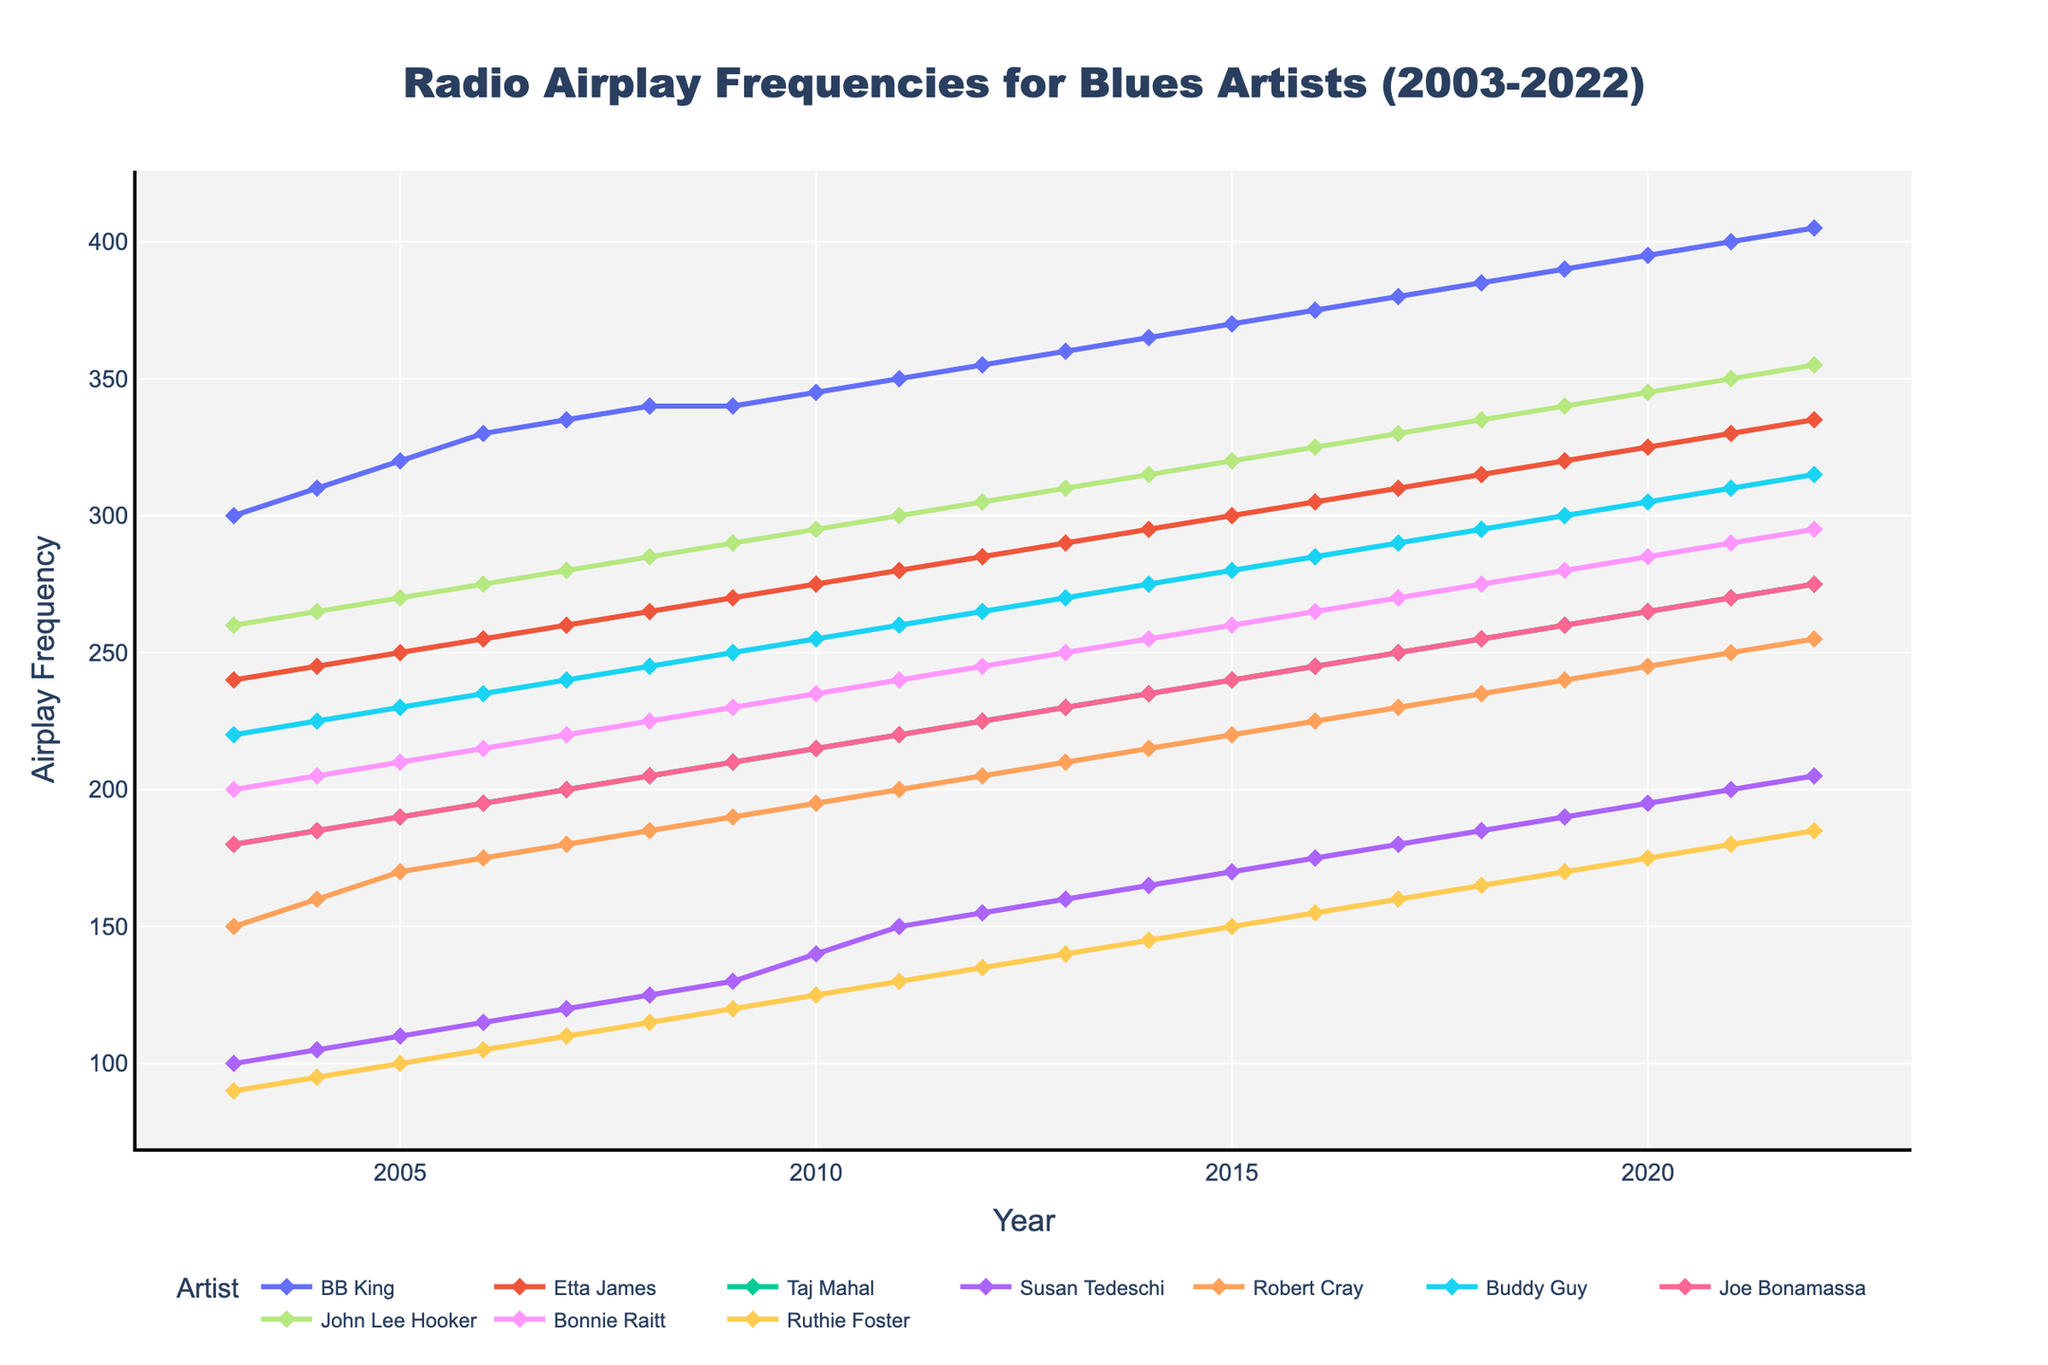What is the title of the figure? The title is displayed at the top center of the figure.
Answer: Radio Airplay Frequencies for Blues Artists (2003-2022) Which artist had the highest airplay frequency in 2010? Look at the year 2010 on the x-axis and find the artist with the highest point on the y-axis for that year.
Answer: BB King What was the airplay frequency for Ruthie Foster in 2015? Follow the 2015 mark on the x-axis and trace upwards to find Ruthie Foster's line, then look at the y-axis value.
Answer: 150 How many data points are there for each artist? Count the number of years (data points) represented in the x-axis or in the dataset for each artist.
Answer: 20 Which artist showed the greatest increase in airplay frequency between 2003 and 2022? Calculate the difference in airplay frequency for each artist between 2003 and 2022, and identify the artist with the largest difference.
Answer: BB King Whose airplay frequency remained the most stable over the 20 years? Identify the artist whose line on the plot shows the least variation (most horizontal line).
Answer: Ruthie Foster In which year did Buddy Guy's airplay frequency surpass 300? Trace Buddy Guy's line and identify the first year where the value on the y-axis goes beyond 300.
Answer: 2017 What is the average airplay frequency for Susan Tedeschi over the 20 years? Sum Susan Tedeschi's airplay frequencies for all years and divide by the number of years. (100+105+110+115+120+125+130+140+150+155+160+165+170+175+180+185+190+195+200+205) ÷ 20 = 152.5
Answer: 152.5 Who had a higher airplay frequency in 2012, John Lee Hooker or Etta James? Compare the y-axis values for both John Lee Hooker and Etta James in 2012.
Answer: John Lee Hooker In which years did Taj Mahal's airplay frequency remain constant, if any? Identify any horizontal segments in Taj Mahal's line which indicate constant airplay over multiple years.
Answer: 2008-2009 